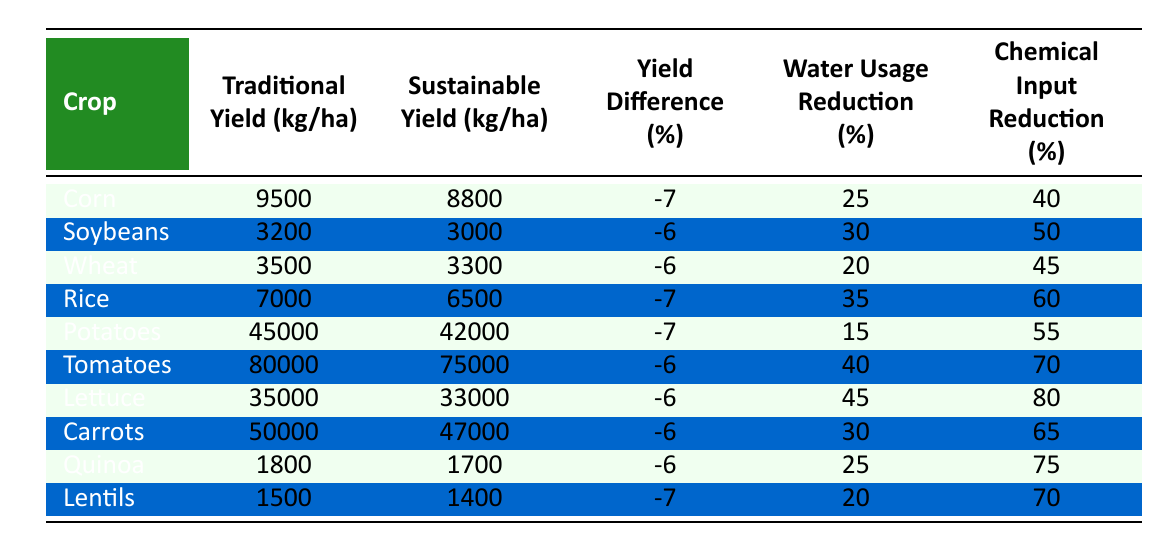What crop has the highest traditional yield? Looking at the "Traditional Yield" column, the highest value is 80,000 kg/ha for Tomatoes.
Answer: Tomatoes Which crop shows the least reduction in water usage? By comparing the "Water Usage Reduction" percentages, Potatoes show the least reduction at 15%.
Answer: Potatoes What is the yield difference percentage for Rice? The "Yield Difference (%)" for Rice is -7%, as indicated in the table.
Answer: -7% How much higher is the traditional yield of Corn compared to its sustainable yield? The traditional yield of Corn is 9,500 kg/ha while the sustainable yield is 8,800 kg/ha. The difference is 9,500 - 8,800 = 700 kg/ha.
Answer: 700 kg/ha Which crop has the highest reduction in chemical input? The "Chemical Input Reduction (%)" shows that Lettuce has the highest reduction at 80%.
Answer: Lettuce Is the yield difference for Lentils greater than the yield difference for Soybeans? Lentils have a yield difference of -7% while Soybeans have -6%. Since -7% is less than -6%, the yield difference for Lentils is greater.
Answer: Yes Calculate the average sustainable yield across all crops. The sustainable yields are: 8,800 + 3,000 + 3,300 + 6,500 + 42,000 + 75,000 + 33,000 + 47,000 + 1,700 + 1,400 = 218,000 kg/ha. There are 10 crops, so the average is 218,000 / 10 = 21,800 kg/ha.
Answer: 21,800 kg/ha What is the total yield difference percentage for all crops combined? The yield differences are: -7, -6, -6, -7, -7, -6, -6, -6, -6, -7, which sums up to -63%. Dividing by the number of crops gives an average of -63% / 10 = -6.3%.
Answer: -6.3% Which crop has the highest total yield under traditional farming? The highest total yield under traditional farming is for Tomatoes at 80,000 kg/ha.
Answer: Tomatoes How many crops have a water usage reduction of over 30%? The crops with over 30% water usage reduction are Corn, Soybeans, Rice, Tomatoes, Lettuce, Carrots, and Quinoa, amounting to 7 crops.
Answer: 7 crops 